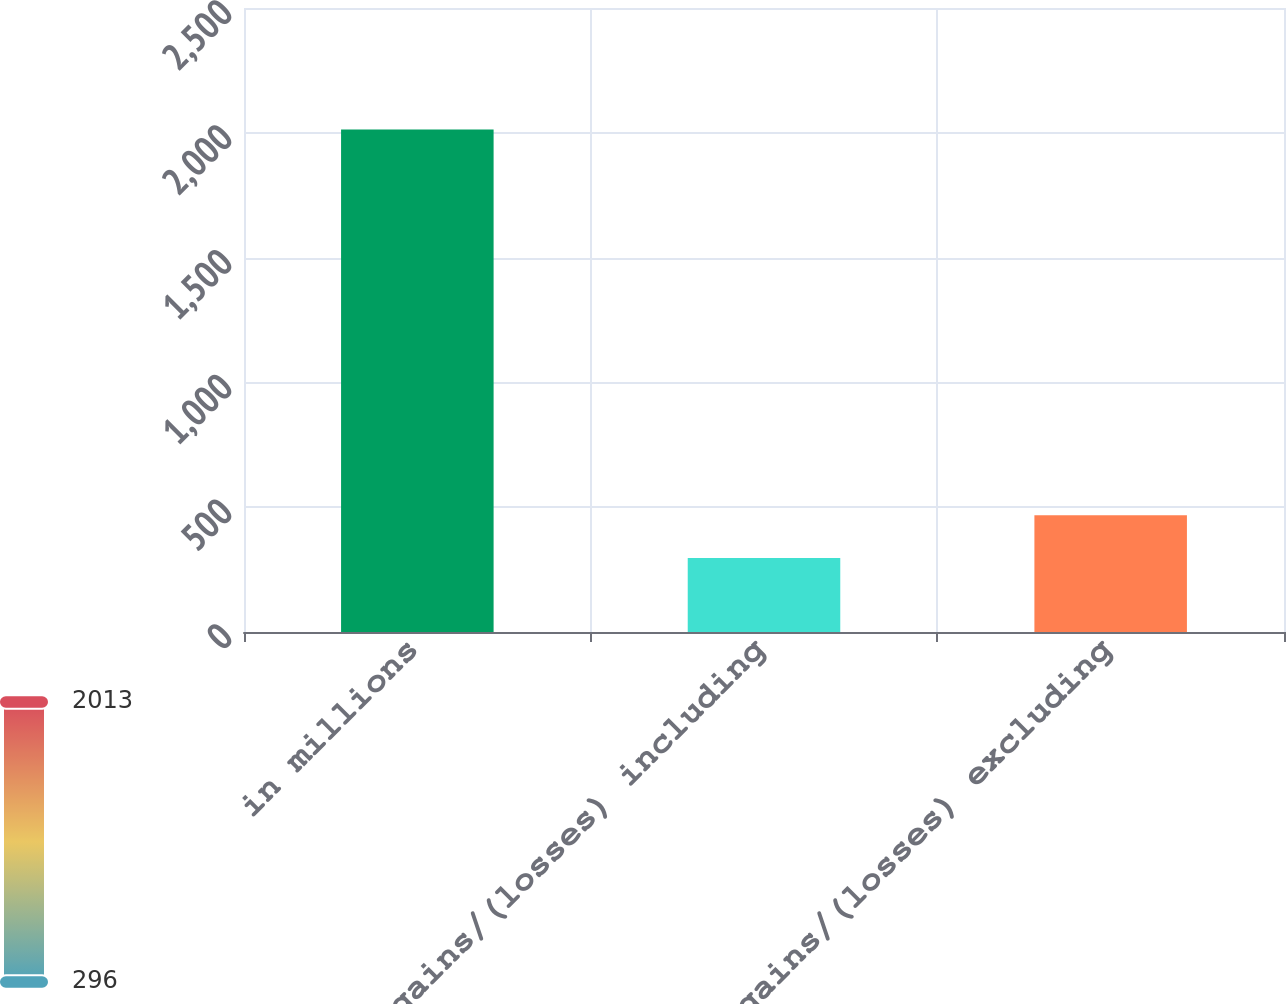Convert chart to OTSL. <chart><loc_0><loc_0><loc_500><loc_500><bar_chart><fcel>in millions<fcel>Net gains/(losses) including<fcel>Net gains/(losses) excluding<nl><fcel>2013<fcel>296<fcel>467.7<nl></chart> 